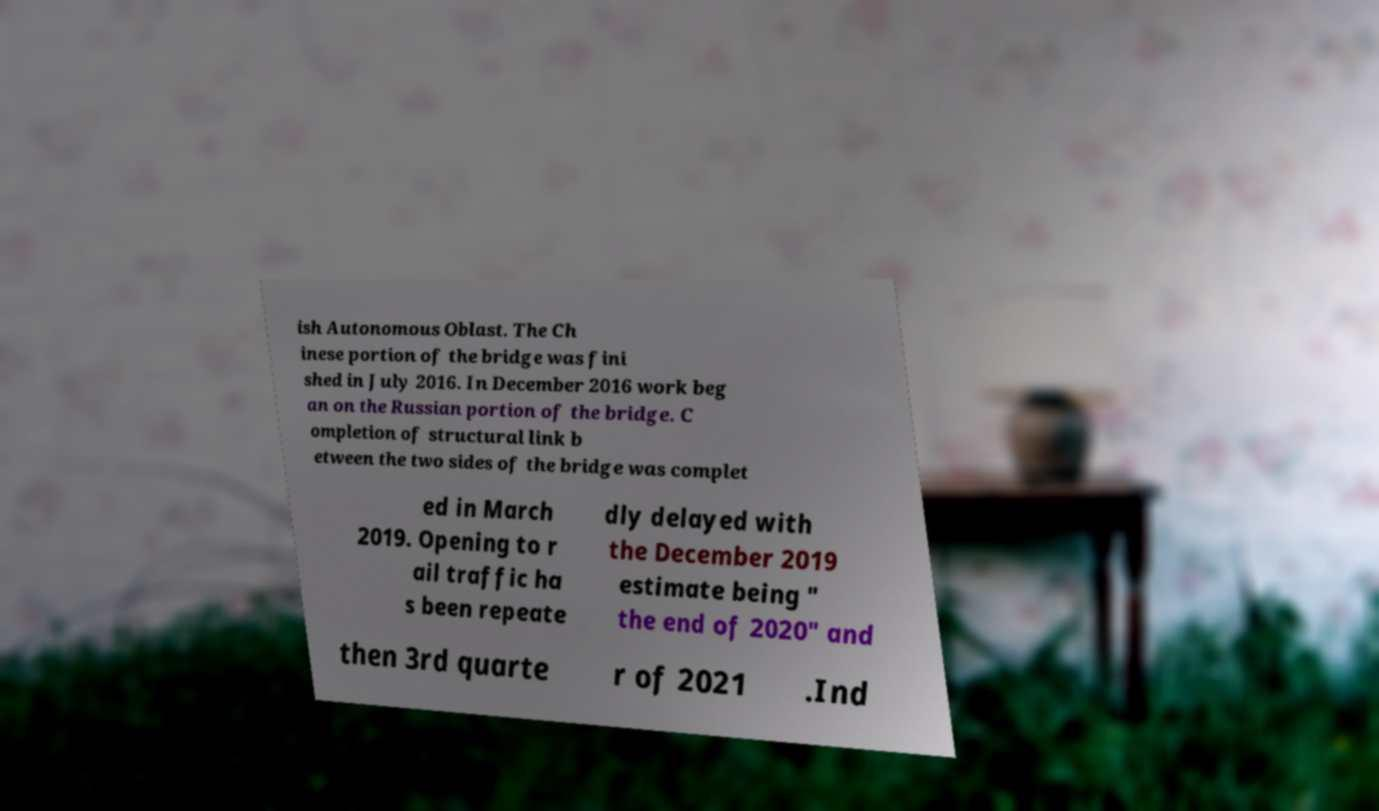Can you accurately transcribe the text from the provided image for me? ish Autonomous Oblast. The Ch inese portion of the bridge was fini shed in July 2016. In December 2016 work beg an on the Russian portion of the bridge. C ompletion of structural link b etween the two sides of the bridge was complet ed in March 2019. Opening to r ail traffic ha s been repeate dly delayed with the December 2019 estimate being " the end of 2020" and then 3rd quarte r of 2021 .Ind 